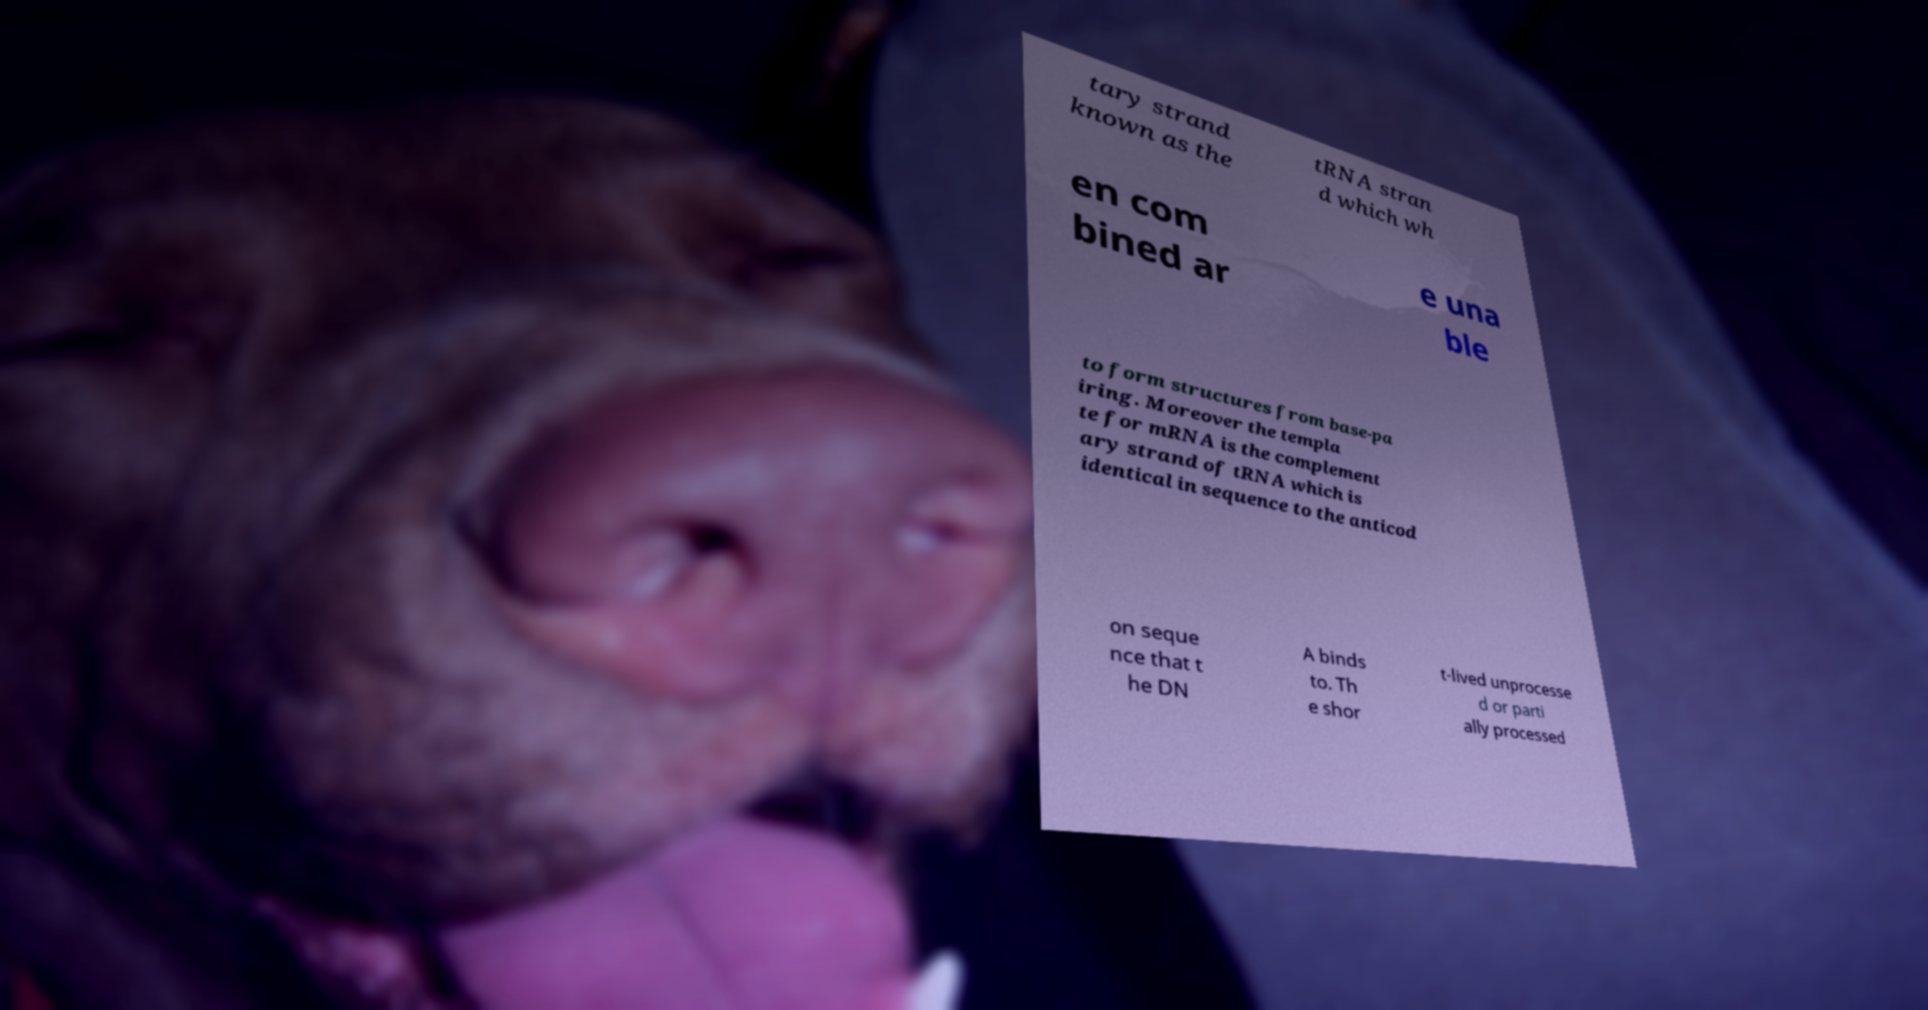There's text embedded in this image that I need extracted. Can you transcribe it verbatim? tary strand known as the tRNA stran d which wh en com bined ar e una ble to form structures from base-pa iring. Moreover the templa te for mRNA is the complement ary strand of tRNA which is identical in sequence to the anticod on seque nce that t he DN A binds to. Th e shor t-lived unprocesse d or parti ally processed 